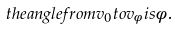<formula> <loc_0><loc_0><loc_500><loc_500>t h e a n g l e f r o m v _ { 0 } t o v _ { \phi } i s \phi .</formula> 